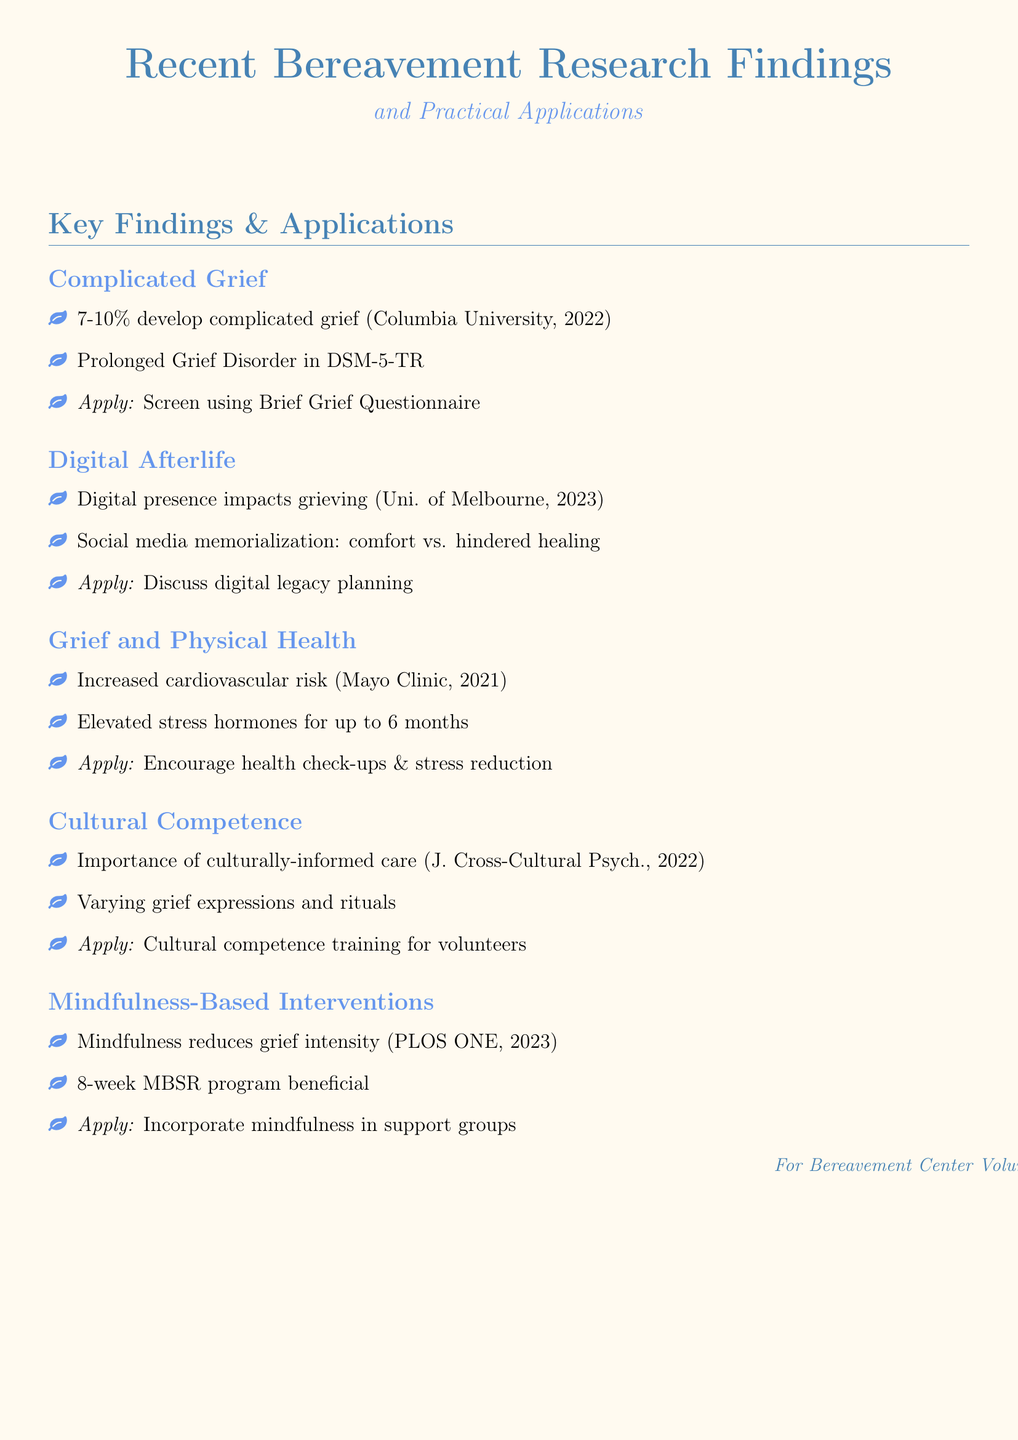What percentage of bereaved individuals develop complicated grief? The document states that 7-10% of bereaved individuals develop complicated grief according to a study by Columbia University.
Answer: 7-10% What application is suggested for addressing complicated grief? The document suggests screening clients for complicated grief symptoms using the Brief Grief Questionnaire as an application.
Answer: Brief Grief Questionnaire What factor may hinder healing during the grieving process? The impact of social media memorialization can hinder healing, as discussed in the research from the University of Melbourne.
Answer: Social media memorialization What did the Mayo Clinic study link bereavement to? The document mentions that the Mayo Clinic study linked bereavement to increased risk of cardiovascular issues.
Answer: Cardiovascular issues What year did the Journal of Cross-Cultural Psychology publish findings on cultural competence in grief support? The document specifies findings from the Journal of Cross-Cultural Psychology published in 2022 regarding culturally-informed bereavement care.
Answer: 2022 Which mindfulness program is mentioned as particularly beneficial? The document identifies the 8-week Mindfulness-Based Stress Reduction (MBSR) program as particularly beneficial in reducing grief intensity.
Answer: 8-week Mindfulness-Based Stress Reduction (MBSR) What is the role of stress hormones after loss? According to the document, stress hormones are elevated for up to 6 months after loss.
Answer: 6 months What type of training is recommended for volunteers? The document recommends providing cultural competence training for volunteers to address the varying grief expressions and rituals.
Answer: Cultural competence training What is a suggested application for mindfulness in support groups? The document suggests incorporating mindfulness exercises into support groups as a practical application.
Answer: Incorporate mindfulness exercises 